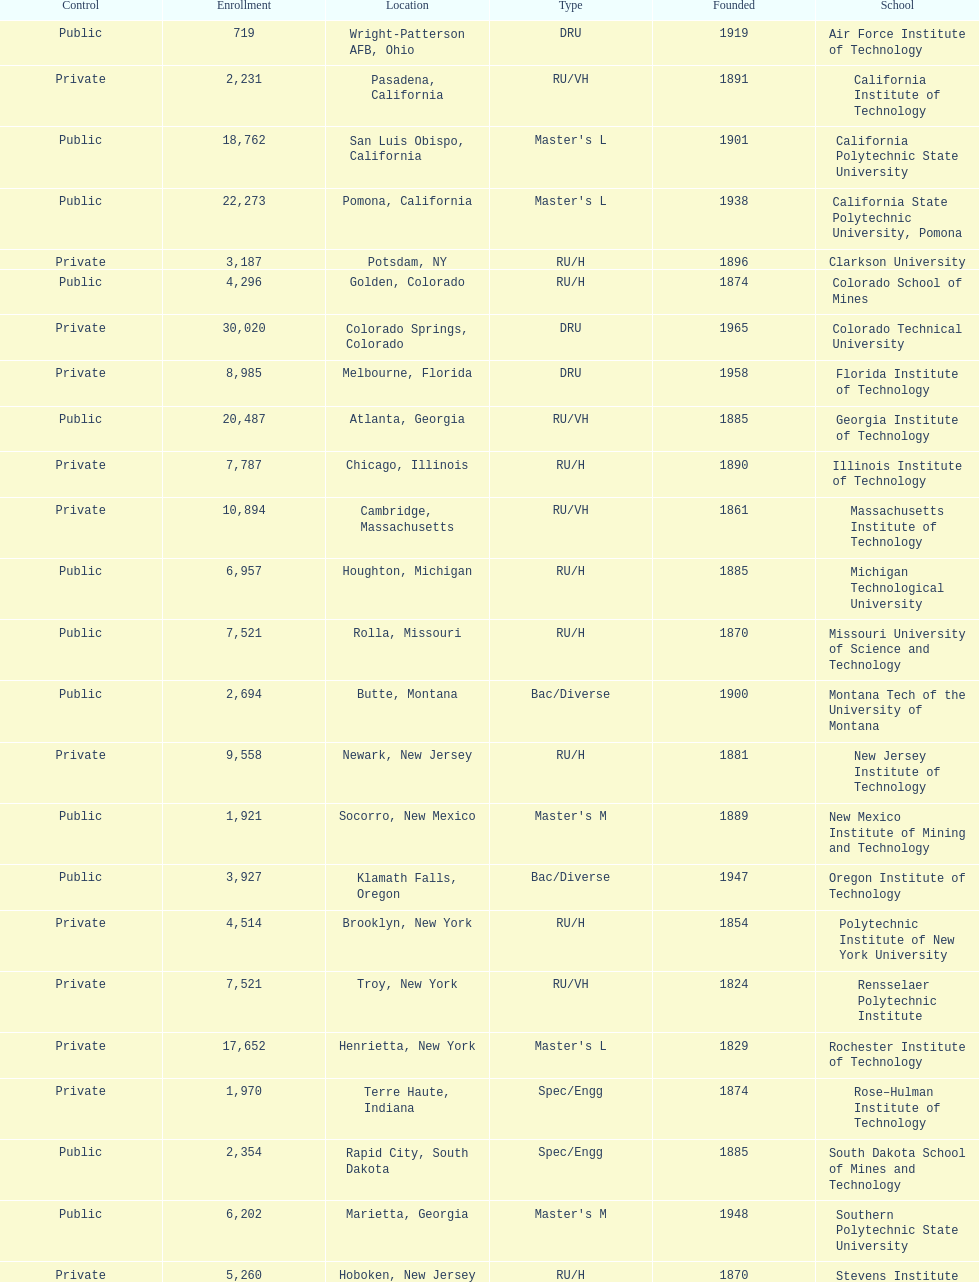What is the count of us technical schools in the state of california? 3. Write the full table. {'header': ['Control', 'Enrollment', 'Location', 'Type', 'Founded', 'School'], 'rows': [['Public', '719', 'Wright-Patterson AFB, Ohio', 'DRU', '1919', 'Air Force Institute of Technology'], ['Private', '2,231', 'Pasadena, California', 'RU/VH', '1891', 'California Institute of Technology'], ['Public', '18,762', 'San Luis Obispo, California', "Master's L", '1901', 'California Polytechnic State University'], ['Public', '22,273', 'Pomona, California', "Master's L", '1938', 'California State Polytechnic University, Pomona'], ['Private', '3,187', 'Potsdam, NY', 'RU/H', '1896', 'Clarkson University'], ['Public', '4,296', 'Golden, Colorado', 'RU/H', '1874', 'Colorado School of Mines'], ['Private', '30,020', 'Colorado Springs, Colorado', 'DRU', '1965', 'Colorado Technical University'], ['Private', '8,985', 'Melbourne, Florida', 'DRU', '1958', 'Florida Institute of Technology'], ['Public', '20,487', 'Atlanta, Georgia', 'RU/VH', '1885', 'Georgia Institute of Technology'], ['Private', '7,787', 'Chicago, Illinois', 'RU/H', '1890', 'Illinois Institute of Technology'], ['Private', '10,894', 'Cambridge, Massachusetts', 'RU/VH', '1861', 'Massachusetts Institute of Technology'], ['Public', '6,957', 'Houghton, Michigan', 'RU/H', '1885', 'Michigan Technological University'], ['Public', '7,521', 'Rolla, Missouri', 'RU/H', '1870', 'Missouri University of Science and Technology'], ['Public', '2,694', 'Butte, Montana', 'Bac/Diverse', '1900', 'Montana Tech of the University of Montana'], ['Private', '9,558', 'Newark, New Jersey', 'RU/H', '1881', 'New Jersey Institute of Technology'], ['Public', '1,921', 'Socorro, New Mexico', "Master's M", '1889', 'New Mexico Institute of Mining and Technology'], ['Public', '3,927', 'Klamath Falls, Oregon', 'Bac/Diverse', '1947', 'Oregon Institute of Technology'], ['Private', '4,514', 'Brooklyn, New York', 'RU/H', '1854', 'Polytechnic Institute of New York University'], ['Private', '7,521', 'Troy, New York', 'RU/VH', '1824', 'Rensselaer Polytechnic Institute'], ['Private', '17,652', 'Henrietta, New York', "Master's L", '1829', 'Rochester Institute of Technology'], ['Private', '1,970', 'Terre Haute, Indiana', 'Spec/Engg', '1874', 'Rose–Hulman Institute of Technology'], ['Public', '2,354', 'Rapid City, South Dakota', 'Spec/Engg', '1885', 'South Dakota School of Mines and Technology'], ['Public', '6,202', 'Marietta, Georgia', "Master's M", '1948', 'Southern Polytechnic State University'], ['Private', '5,260', 'Hoboken, New Jersey', 'RU/H', '1870', 'Stevens Institute of Technology'], ['Public', '32,327', 'Lubbock, Texas', 'RU/H', '1923', 'Texas Tech University'], ['Public', '9,339', 'Menomonie, Wisconsin', "Master's L", '1891', 'University of Wisconsin–Stout'], ['Public', '30,739', 'Blacksburg, Virginia', 'RU/VH', '1872', 'Virginia Polytechnic Institute and State University'], ['Private', '5,071', 'Worcester, Massachusetts', 'DRU', '1865', 'Worcester Polytechnic Institute']]} 